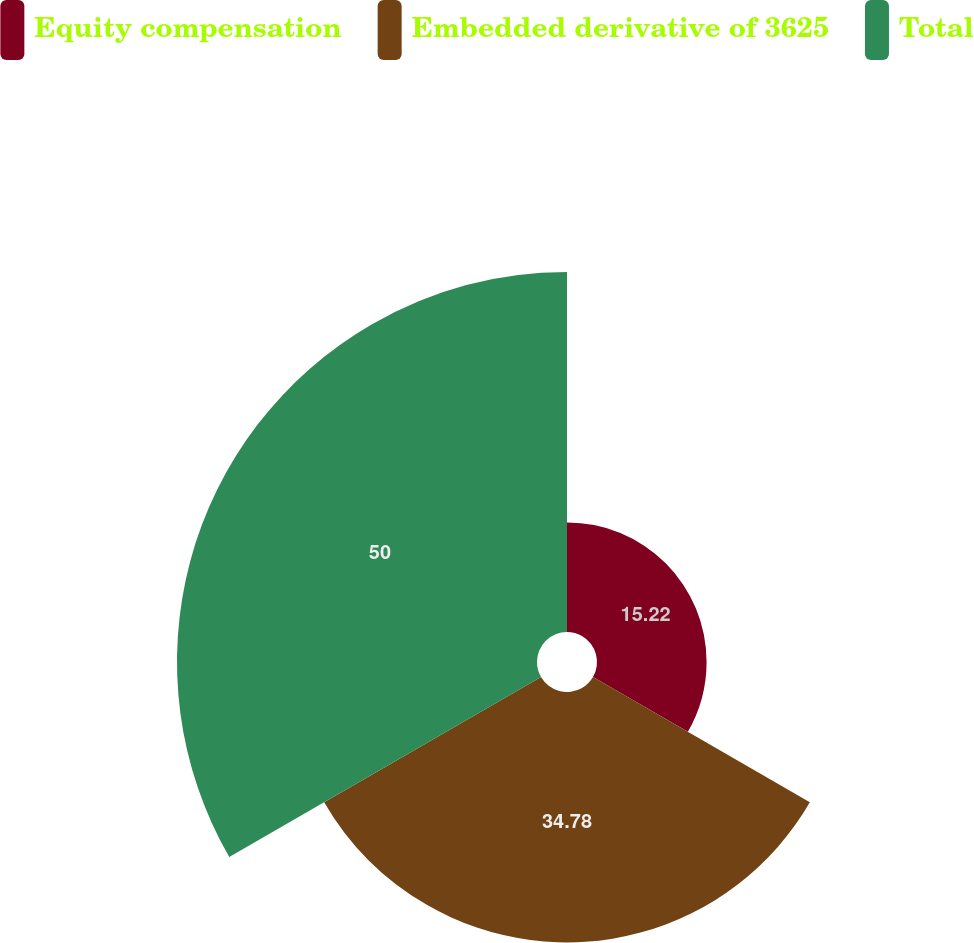Convert chart to OTSL. <chart><loc_0><loc_0><loc_500><loc_500><pie_chart><fcel>Equity compensation<fcel>Embedded derivative of 3625<fcel>Total<nl><fcel>15.22%<fcel>34.78%<fcel>50.0%<nl></chart> 